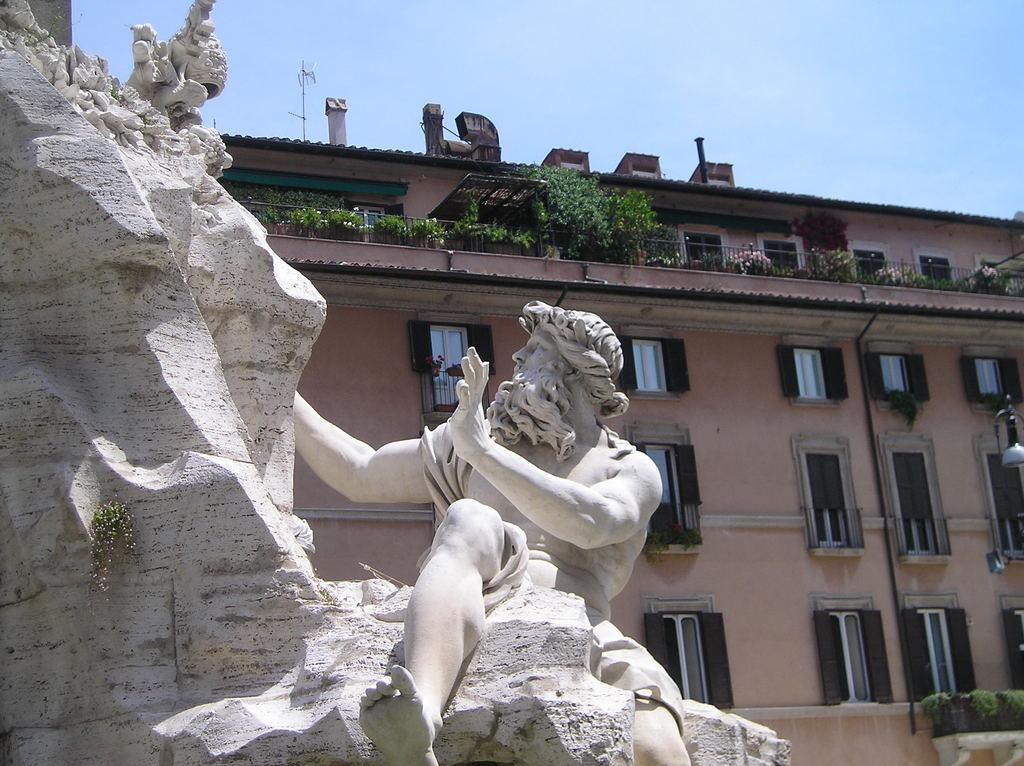What is the main subject of the image? There is a sculpture in the image. What can be seen in the background of the image? There is a building and windows visible in the background of the image. What is visible above the building in the image? The sky is visible in the background of the image. How many wheels are attached to the sculpture in the image? There are no wheels present on the sculpture in the image. What type of wall can be seen surrounding the sculpture in the image? There is no wall surrounding the sculpture in the image. 